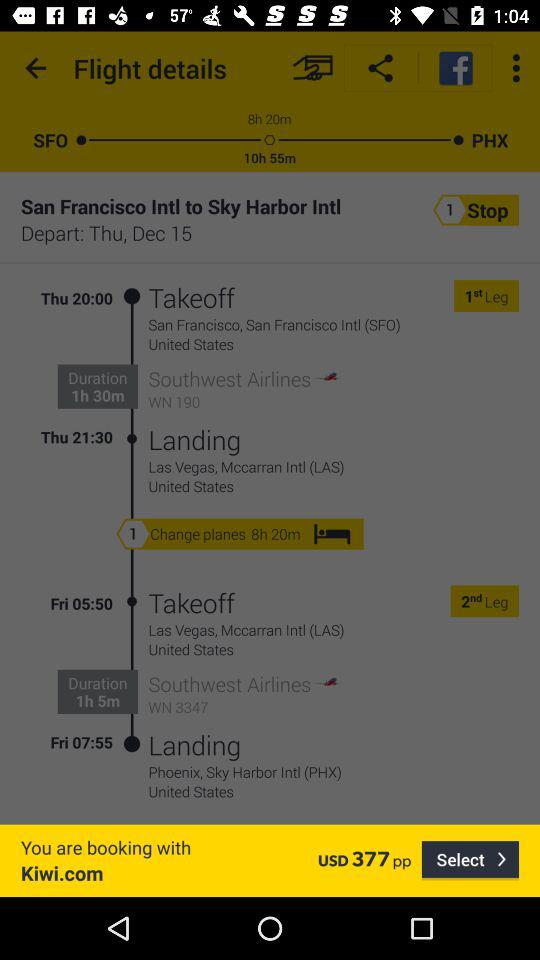From which application has the booking been processed? The booking has been processed by the application "Kiwi.com". 